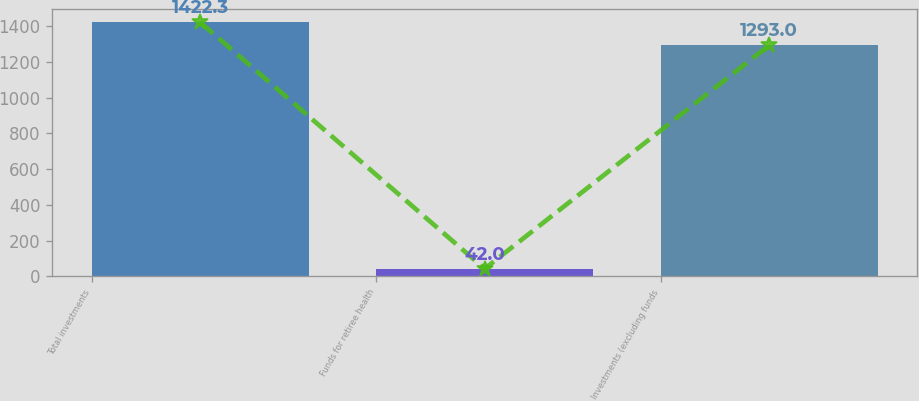Convert chart to OTSL. <chart><loc_0><loc_0><loc_500><loc_500><bar_chart><fcel>Total investments<fcel>Funds for retiree health<fcel>Investments (excluding funds<nl><fcel>1422.3<fcel>42<fcel>1293<nl></chart> 